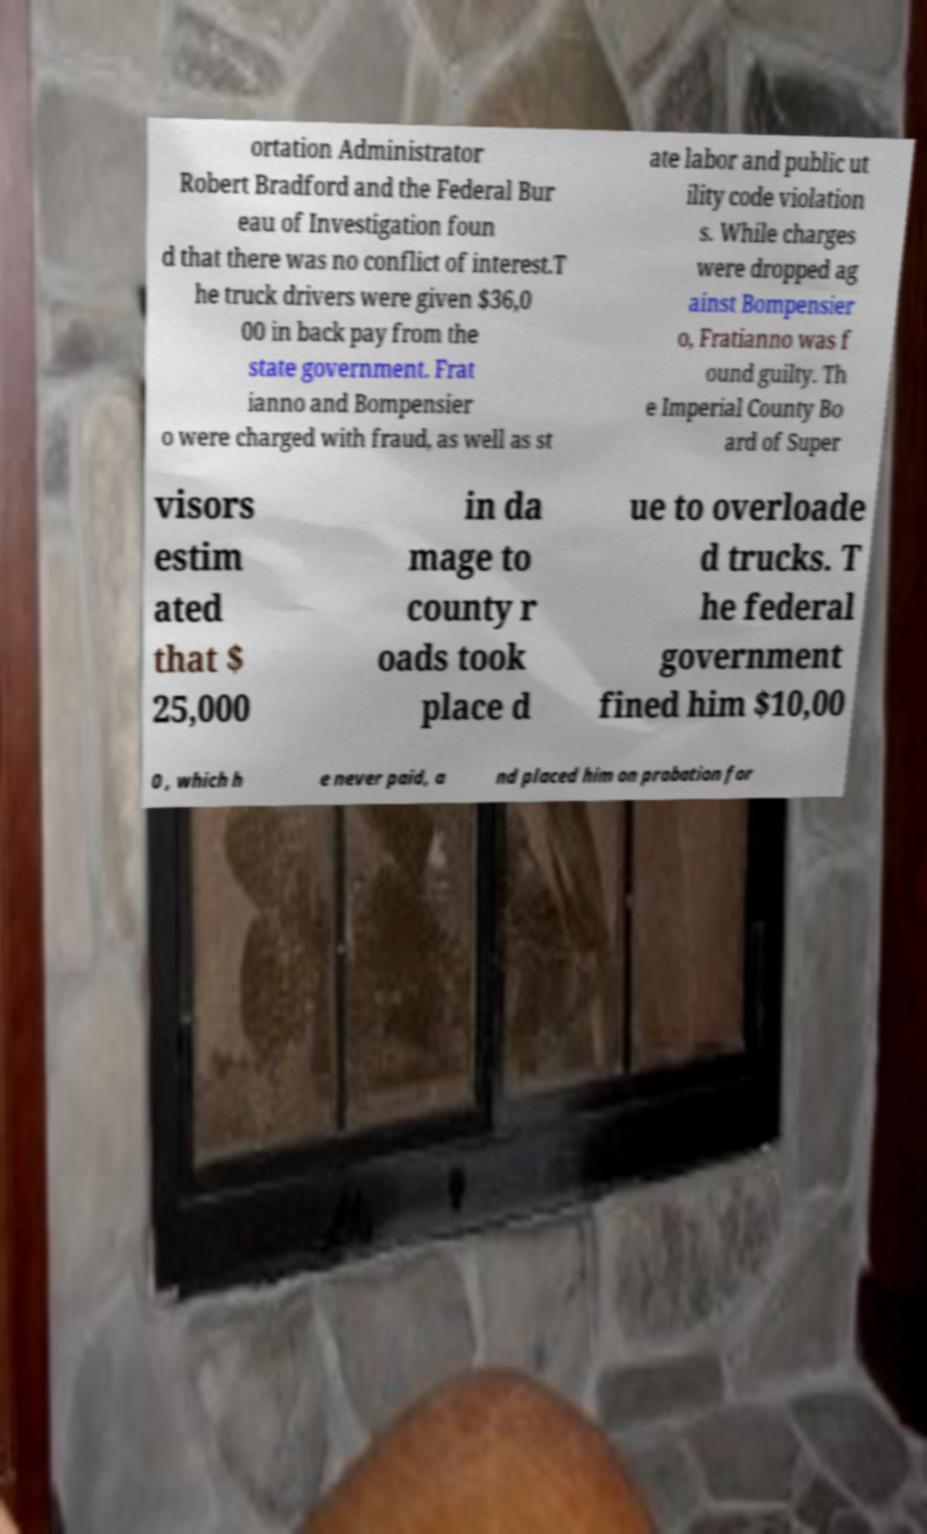Please read and relay the text visible in this image. What does it say? ortation Administrator Robert Bradford and the Federal Bur eau of Investigation foun d that there was no conflict of interest.T he truck drivers were given $36,0 00 in back pay from the state government. Frat ianno and Bompensier o were charged with fraud, as well as st ate labor and public ut ility code violation s. While charges were dropped ag ainst Bompensier o, Fratianno was f ound guilty. Th e Imperial County Bo ard of Super visors estim ated that $ 25,000 in da mage to county r oads took place d ue to overloade d trucks. T he federal government fined him $10,00 0 , which h e never paid, a nd placed him on probation for 